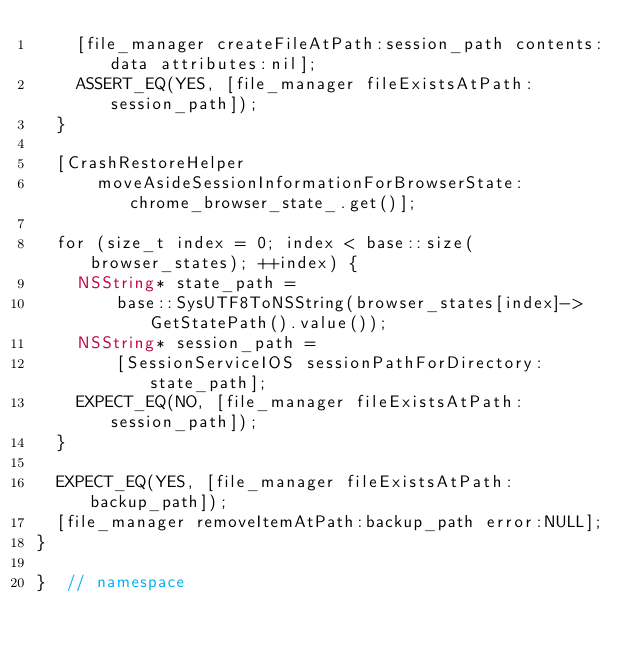<code> <loc_0><loc_0><loc_500><loc_500><_ObjectiveC_>    [file_manager createFileAtPath:session_path contents:data attributes:nil];
    ASSERT_EQ(YES, [file_manager fileExistsAtPath:session_path]);
  }

  [CrashRestoreHelper
      moveAsideSessionInformationForBrowserState:chrome_browser_state_.get()];

  for (size_t index = 0; index < base::size(browser_states); ++index) {
    NSString* state_path =
        base::SysUTF8ToNSString(browser_states[index]->GetStatePath().value());
    NSString* session_path =
        [SessionServiceIOS sessionPathForDirectory:state_path];
    EXPECT_EQ(NO, [file_manager fileExistsAtPath:session_path]);
  }

  EXPECT_EQ(YES, [file_manager fileExistsAtPath:backup_path]);
  [file_manager removeItemAtPath:backup_path error:NULL];
}

}  // namespace
</code> 